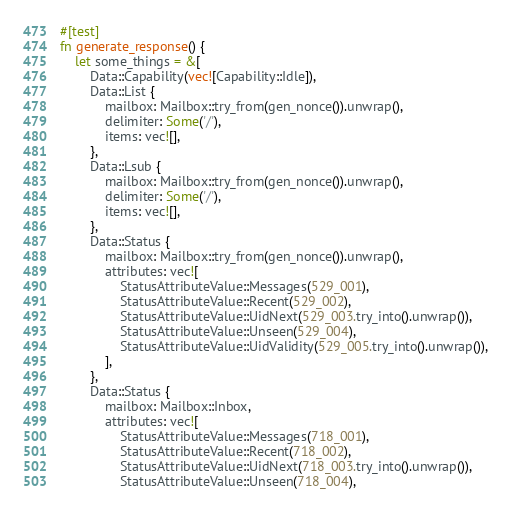Convert code to text. <code><loc_0><loc_0><loc_500><loc_500><_Rust_>
#[test]
fn generate_response() {
    let some_things = &[
        Data::Capability(vec![Capability::Idle]),
        Data::List {
            mailbox: Mailbox::try_from(gen_nonce()).unwrap(),
            delimiter: Some('/'),
            items: vec![],
        },
        Data::Lsub {
            mailbox: Mailbox::try_from(gen_nonce()).unwrap(),
            delimiter: Some('/'),
            items: vec![],
        },
        Data::Status {
            mailbox: Mailbox::try_from(gen_nonce()).unwrap(),
            attributes: vec![
                StatusAttributeValue::Messages(529_001),
                StatusAttributeValue::Recent(529_002),
                StatusAttributeValue::UidNext(529_003.try_into().unwrap()),
                StatusAttributeValue::Unseen(529_004),
                StatusAttributeValue::UidValidity(529_005.try_into().unwrap()),
            ],
        },
        Data::Status {
            mailbox: Mailbox::Inbox,
            attributes: vec![
                StatusAttributeValue::Messages(718_001),
                StatusAttributeValue::Recent(718_002),
                StatusAttributeValue::UidNext(718_003.try_into().unwrap()),
                StatusAttributeValue::Unseen(718_004),</code> 